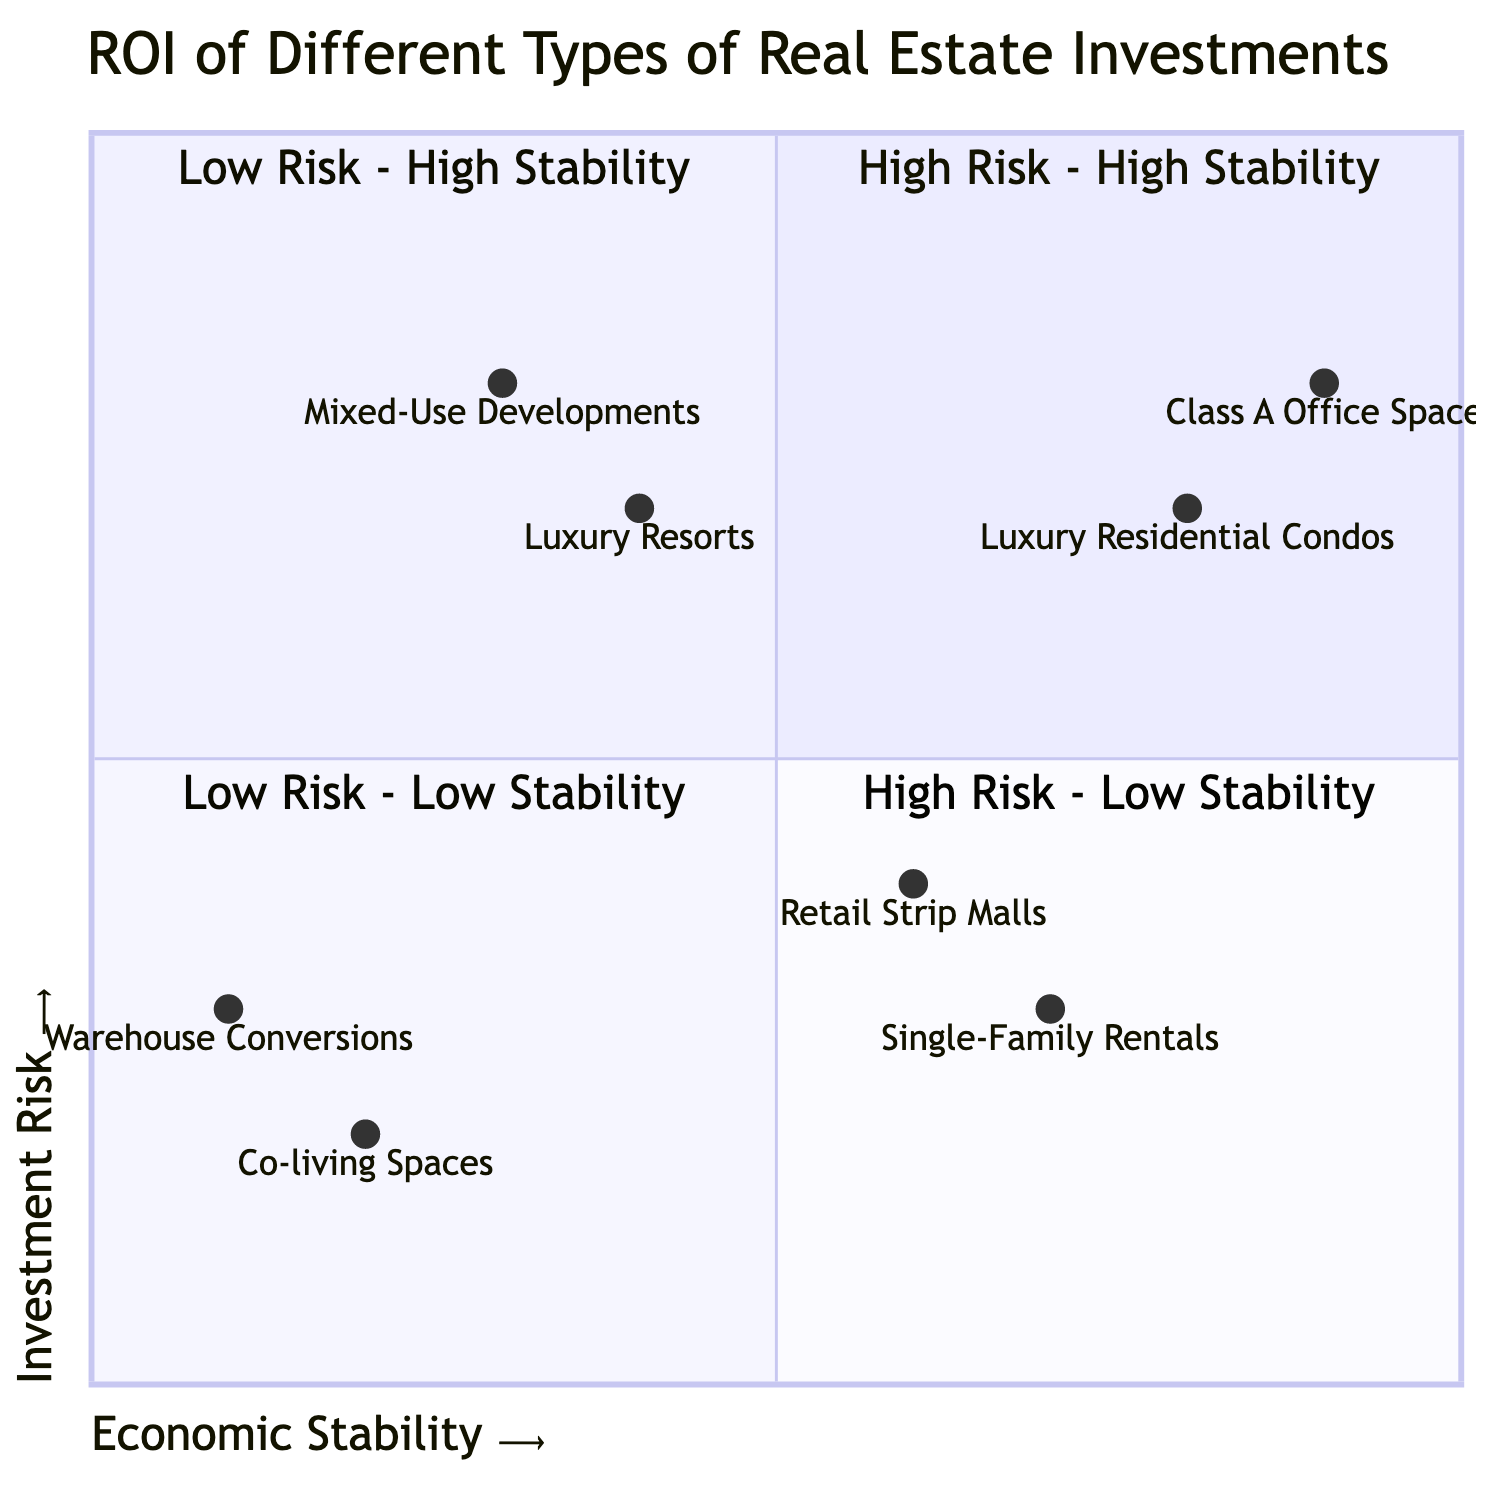What type of real estate investment is found in the "Low Risk - High Stability" quadrant? The "Low Risk - High Stability" quadrant includes "Luxury Residential Condos" and "Class A Office Space." Both these types are positioned there because they offer stable returns with lower associated risks.
Answer: Luxury Residential Condos, Class A Office Space Which real estate type has the highest risk in a low stability market? "Co-living Spaces" is the only type listed in the "High Risk - Low Stability" quadrant, indicating that it carries the highest risk in a market characterized by low stability.
Answer: Co-living Spaces How many types of real estate investments are categorized as "Low Risk - Low Stability"? There are two types of real estate investments in the "Low Risk - Low Stability" quadrant: "Single-Family Rentals" and "Retail Strip Malls." Both are categorized there due to their lower risk despite the unstable market conditions.
Answer: 2 Which quadrant contains mixed-use developments? Mixed-use developments are placed in the "High Risk - High Stability" quadrant, indicating that while these investments are riskier, they are located in stable economic conditions.
Answer: High Risk - High Stability What example is provided for luxury resorts? The example given for luxury resorts is "The Ritz-Carlton, Hawaii," which is a prominent establishment situated in a stable tourist destination.
Answer: The Ritz-Carlton, Hawaii What investment type is indicated as having low economic stability? "Warehouse Conversions" is situated in the "High Risk - Low Stability" quadrant, making it an investment type characterized by low economic stability.
Answer: Warehouse Conversions Which type of investment is deemed lower risk with moderate demand? "Single-Family Rentals" are categorized under "Low Risk - Low Stability," indicating they are seen as safer investments despite moderate demand levels in suburban areas.
Answer: Single-Family Rentals How many real estate types are shown in the "Top Left" quadrant? There are two types of real estate investments featured in the "Top Left" quadrant, both of which present high risk but operate in high stability conditions.
Answer: 2 